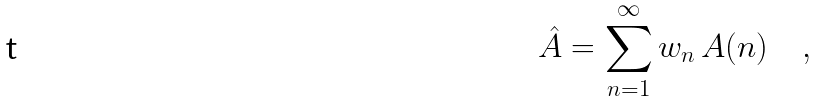Convert formula to latex. <formula><loc_0><loc_0><loc_500><loc_500>\hat { A } = \sum _ { n = 1 } ^ { \infty } w _ { n } \, A ( n ) \quad ,</formula> 